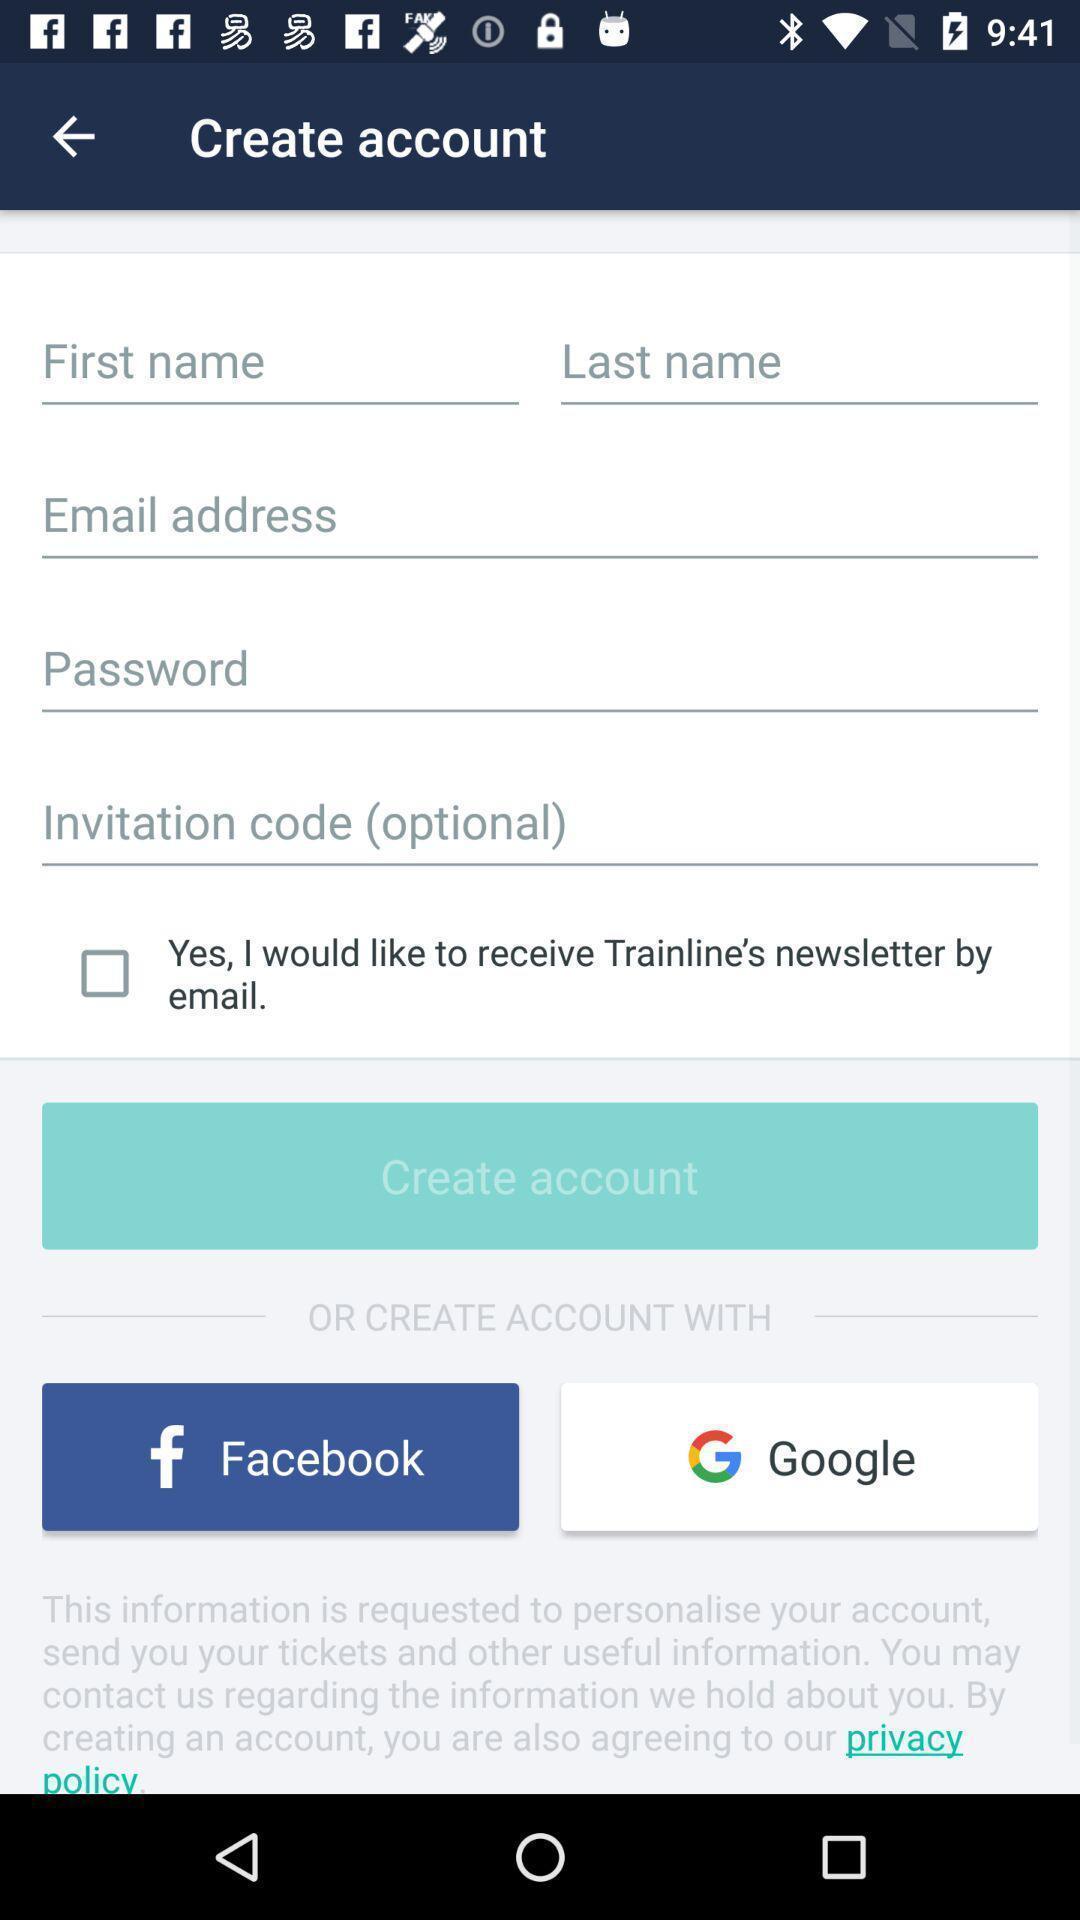Provide a textual representation of this image. Screen showing fields to enter to create account in application. 